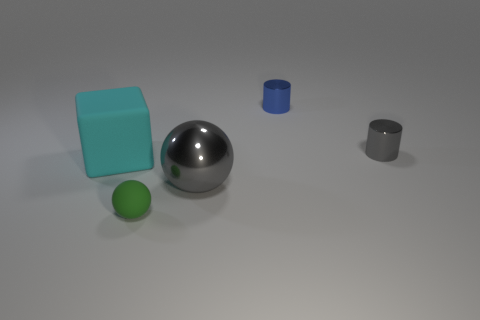Add 5 small green objects. How many objects exist? 10 Subtract all cylinders. How many objects are left? 3 Subtract all matte balls. Subtract all cyan matte blocks. How many objects are left? 3 Add 4 large gray metal objects. How many large gray metal objects are left? 5 Add 3 small gray shiny cylinders. How many small gray shiny cylinders exist? 4 Subtract 0 brown blocks. How many objects are left? 5 